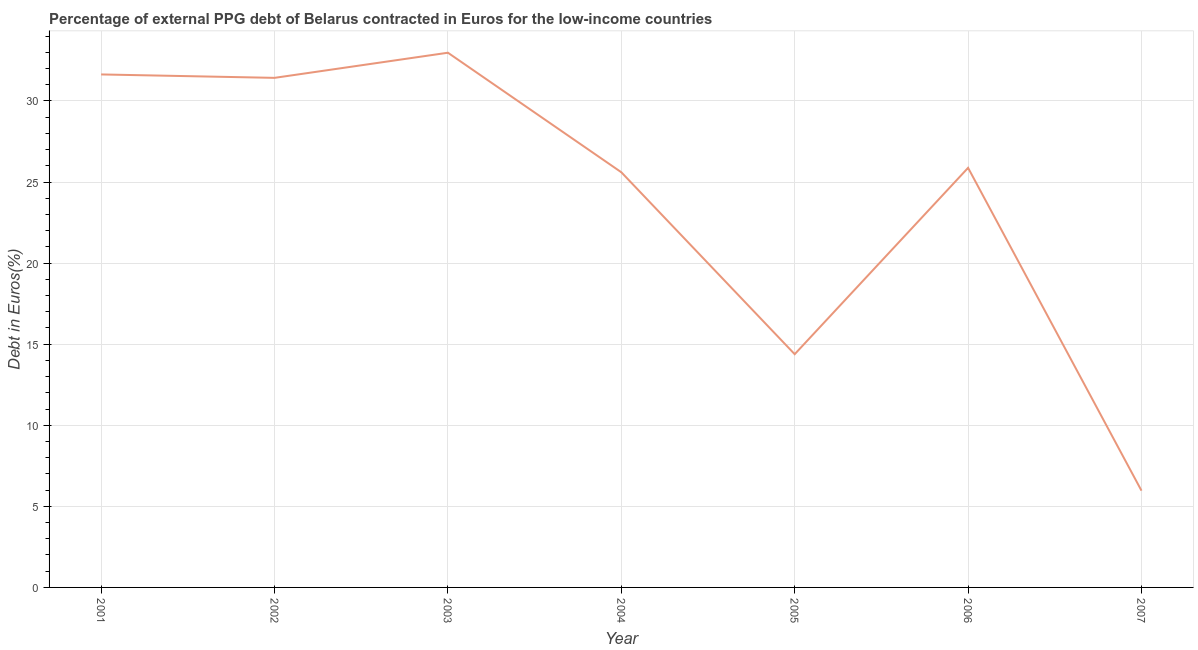What is the currency composition of ppg debt in 2002?
Your response must be concise. 31.42. Across all years, what is the maximum currency composition of ppg debt?
Offer a terse response. 32.97. Across all years, what is the minimum currency composition of ppg debt?
Your answer should be compact. 5.97. What is the sum of the currency composition of ppg debt?
Ensure brevity in your answer.  167.85. What is the difference between the currency composition of ppg debt in 2002 and 2004?
Your answer should be very brief. 5.82. What is the average currency composition of ppg debt per year?
Your response must be concise. 23.98. What is the median currency composition of ppg debt?
Keep it short and to the point. 25.87. In how many years, is the currency composition of ppg debt greater than 31 %?
Offer a very short reply. 3. Do a majority of the years between 2002 and 2005 (inclusive) have currency composition of ppg debt greater than 10 %?
Your answer should be compact. Yes. What is the ratio of the currency composition of ppg debt in 2006 to that in 2007?
Give a very brief answer. 4.34. Is the currency composition of ppg debt in 2001 less than that in 2004?
Your answer should be compact. No. Is the difference between the currency composition of ppg debt in 2001 and 2004 greater than the difference between any two years?
Your answer should be compact. No. What is the difference between the highest and the second highest currency composition of ppg debt?
Offer a very short reply. 1.34. What is the difference between the highest and the lowest currency composition of ppg debt?
Provide a succinct answer. 27.01. In how many years, is the currency composition of ppg debt greater than the average currency composition of ppg debt taken over all years?
Offer a terse response. 5. How many lines are there?
Offer a very short reply. 1. How many years are there in the graph?
Offer a very short reply. 7. Are the values on the major ticks of Y-axis written in scientific E-notation?
Keep it short and to the point. No. Does the graph contain grids?
Your answer should be compact. Yes. What is the title of the graph?
Keep it short and to the point. Percentage of external PPG debt of Belarus contracted in Euros for the low-income countries. What is the label or title of the Y-axis?
Provide a succinct answer. Debt in Euros(%). What is the Debt in Euros(%) of 2001?
Your response must be concise. 31.63. What is the Debt in Euros(%) of 2002?
Offer a very short reply. 31.42. What is the Debt in Euros(%) of 2003?
Make the answer very short. 32.97. What is the Debt in Euros(%) of 2004?
Make the answer very short. 25.6. What is the Debt in Euros(%) of 2005?
Ensure brevity in your answer.  14.38. What is the Debt in Euros(%) of 2006?
Your response must be concise. 25.87. What is the Debt in Euros(%) of 2007?
Keep it short and to the point. 5.97. What is the difference between the Debt in Euros(%) in 2001 and 2002?
Your answer should be compact. 0.21. What is the difference between the Debt in Euros(%) in 2001 and 2003?
Your response must be concise. -1.34. What is the difference between the Debt in Euros(%) in 2001 and 2004?
Provide a short and direct response. 6.03. What is the difference between the Debt in Euros(%) in 2001 and 2005?
Your response must be concise. 17.25. What is the difference between the Debt in Euros(%) in 2001 and 2006?
Give a very brief answer. 5.76. What is the difference between the Debt in Euros(%) in 2001 and 2007?
Ensure brevity in your answer.  25.67. What is the difference between the Debt in Euros(%) in 2002 and 2003?
Offer a very short reply. -1.55. What is the difference between the Debt in Euros(%) in 2002 and 2004?
Keep it short and to the point. 5.82. What is the difference between the Debt in Euros(%) in 2002 and 2005?
Offer a terse response. 17.04. What is the difference between the Debt in Euros(%) in 2002 and 2006?
Provide a succinct answer. 5.55. What is the difference between the Debt in Euros(%) in 2002 and 2007?
Provide a short and direct response. 25.46. What is the difference between the Debt in Euros(%) in 2003 and 2004?
Provide a short and direct response. 7.37. What is the difference between the Debt in Euros(%) in 2003 and 2005?
Your answer should be very brief. 18.59. What is the difference between the Debt in Euros(%) in 2003 and 2006?
Offer a very short reply. 7.1. What is the difference between the Debt in Euros(%) in 2003 and 2007?
Your response must be concise. 27.01. What is the difference between the Debt in Euros(%) in 2004 and 2005?
Your response must be concise. 11.22. What is the difference between the Debt in Euros(%) in 2004 and 2006?
Your response must be concise. -0.27. What is the difference between the Debt in Euros(%) in 2004 and 2007?
Provide a short and direct response. 19.64. What is the difference between the Debt in Euros(%) in 2005 and 2006?
Give a very brief answer. -11.49. What is the difference between the Debt in Euros(%) in 2005 and 2007?
Your answer should be very brief. 8.42. What is the difference between the Debt in Euros(%) in 2006 and 2007?
Keep it short and to the point. 19.91. What is the ratio of the Debt in Euros(%) in 2001 to that in 2003?
Offer a terse response. 0.96. What is the ratio of the Debt in Euros(%) in 2001 to that in 2004?
Give a very brief answer. 1.24. What is the ratio of the Debt in Euros(%) in 2001 to that in 2005?
Provide a short and direct response. 2.2. What is the ratio of the Debt in Euros(%) in 2001 to that in 2006?
Provide a succinct answer. 1.22. What is the ratio of the Debt in Euros(%) in 2001 to that in 2007?
Your answer should be very brief. 5.3. What is the ratio of the Debt in Euros(%) in 2002 to that in 2003?
Offer a very short reply. 0.95. What is the ratio of the Debt in Euros(%) in 2002 to that in 2004?
Your answer should be compact. 1.23. What is the ratio of the Debt in Euros(%) in 2002 to that in 2005?
Provide a short and direct response. 2.19. What is the ratio of the Debt in Euros(%) in 2002 to that in 2006?
Provide a succinct answer. 1.21. What is the ratio of the Debt in Euros(%) in 2002 to that in 2007?
Provide a short and direct response. 5.27. What is the ratio of the Debt in Euros(%) in 2003 to that in 2004?
Give a very brief answer. 1.29. What is the ratio of the Debt in Euros(%) in 2003 to that in 2005?
Keep it short and to the point. 2.29. What is the ratio of the Debt in Euros(%) in 2003 to that in 2006?
Provide a succinct answer. 1.27. What is the ratio of the Debt in Euros(%) in 2003 to that in 2007?
Provide a short and direct response. 5.53. What is the ratio of the Debt in Euros(%) in 2004 to that in 2005?
Your answer should be compact. 1.78. What is the ratio of the Debt in Euros(%) in 2004 to that in 2007?
Your answer should be compact. 4.29. What is the ratio of the Debt in Euros(%) in 2005 to that in 2006?
Give a very brief answer. 0.56. What is the ratio of the Debt in Euros(%) in 2005 to that in 2007?
Provide a short and direct response. 2.41. What is the ratio of the Debt in Euros(%) in 2006 to that in 2007?
Your response must be concise. 4.34. 